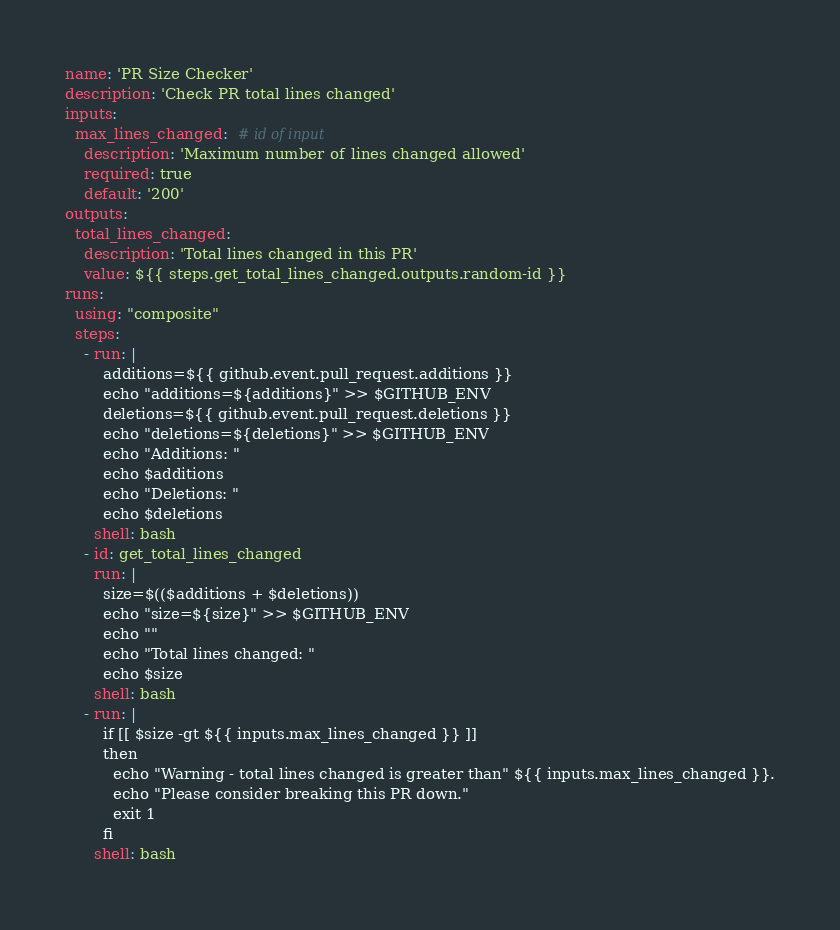<code> <loc_0><loc_0><loc_500><loc_500><_YAML_>name: 'PR Size Checker'
description: 'Check PR total lines changed'
inputs:
  max_lines_changed:  # id of input
    description: 'Maximum number of lines changed allowed'
    required: true
    default: '200'
outputs:
  total_lines_changed:
    description: 'Total lines changed in this PR'
    value: ${{ steps.get_total_lines_changed.outputs.random-id }}
runs:
  using: "composite"
  steps:
    - run: |
        additions=${{ github.event.pull_request.additions }}
        echo "additions=${additions}" >> $GITHUB_ENV
        deletions=${{ github.event.pull_request.deletions }}
        echo "deletions=${deletions}" >> $GITHUB_ENV
        echo "Additions: "
        echo $additions
        echo "Deletions: "
        echo $deletions
      shell: bash
    - id: get_total_lines_changed
      run: |
        size=$(($additions + $deletions))
        echo "size=${size}" >> $GITHUB_ENV
        echo ""
        echo "Total lines changed: "
        echo $size
      shell: bash
    - run: |
        if [[ $size -gt ${{ inputs.max_lines_changed }} ]]
        then
          echo "Warning - total lines changed is greater than" ${{ inputs.max_lines_changed }}.
          echo "Please consider breaking this PR down."
          exit 1
        fi
      shell: bash
</code> 